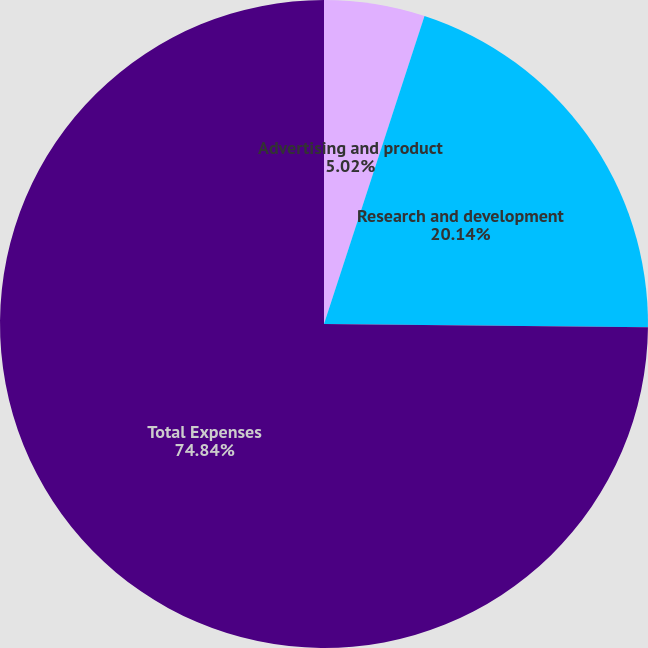<chart> <loc_0><loc_0><loc_500><loc_500><pie_chart><fcel>Advertising and product<fcel>Research and development<fcel>Total Expenses<nl><fcel>5.02%<fcel>20.14%<fcel>74.84%<nl></chart> 